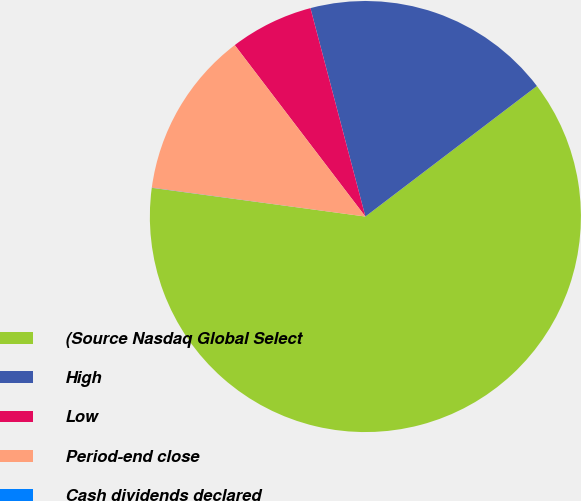Convert chart to OTSL. <chart><loc_0><loc_0><loc_500><loc_500><pie_chart><fcel>(Source Nasdaq Global Select<fcel>High<fcel>Low<fcel>Period-end close<fcel>Cash dividends declared<nl><fcel>62.47%<fcel>18.75%<fcel>6.26%<fcel>12.5%<fcel>0.01%<nl></chart> 